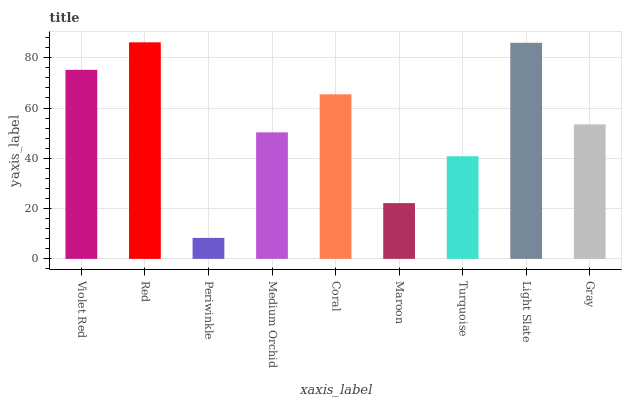Is Periwinkle the minimum?
Answer yes or no. Yes. Is Red the maximum?
Answer yes or no. Yes. Is Red the minimum?
Answer yes or no. No. Is Periwinkle the maximum?
Answer yes or no. No. Is Red greater than Periwinkle?
Answer yes or no. Yes. Is Periwinkle less than Red?
Answer yes or no. Yes. Is Periwinkle greater than Red?
Answer yes or no. No. Is Red less than Periwinkle?
Answer yes or no. No. Is Gray the high median?
Answer yes or no. Yes. Is Gray the low median?
Answer yes or no. Yes. Is Turquoise the high median?
Answer yes or no. No. Is Turquoise the low median?
Answer yes or no. No. 